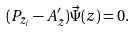<formula> <loc_0><loc_0><loc_500><loc_500>( P _ { \bar { z } _ { i } } - A ^ { \prime } _ { \bar { z } } ) { \vec { \Psi } } ( z ) = 0 .</formula> 